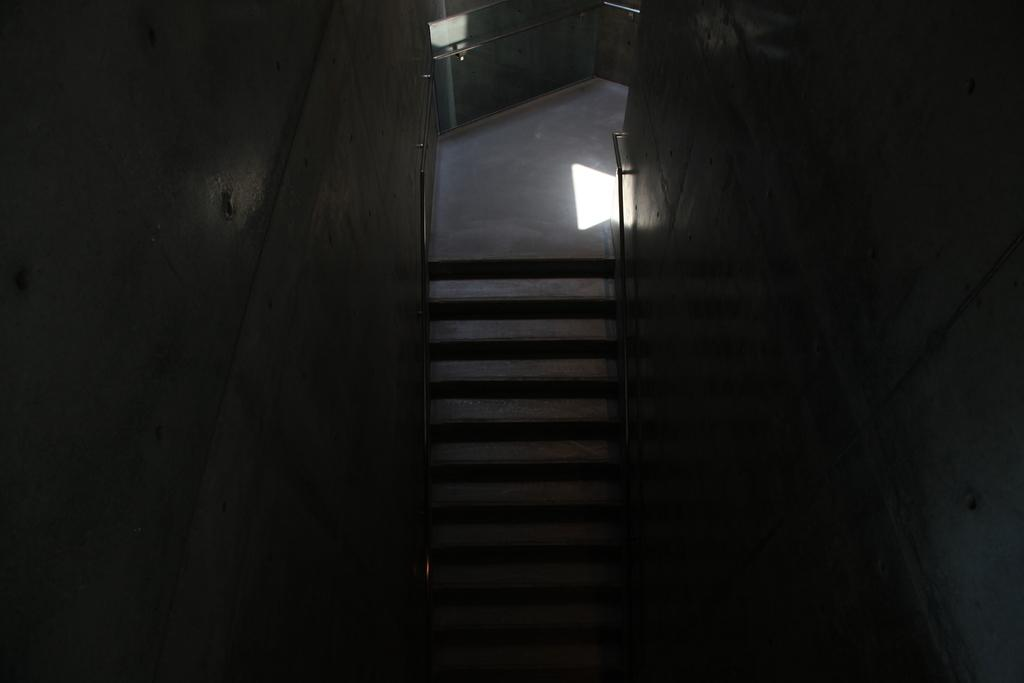What architectural feature is present in the image? There are steps in the image. What else can be seen in the image besides the steps? There is a wall in the image. What type of ship can be seen sailing on the lake in the image? There is no ship or lake present in the image; it only features steps and a wall. What is the tendency of the wall in the image? The image does not provide information about the wall's tendency, as it only shows its presence and location. 